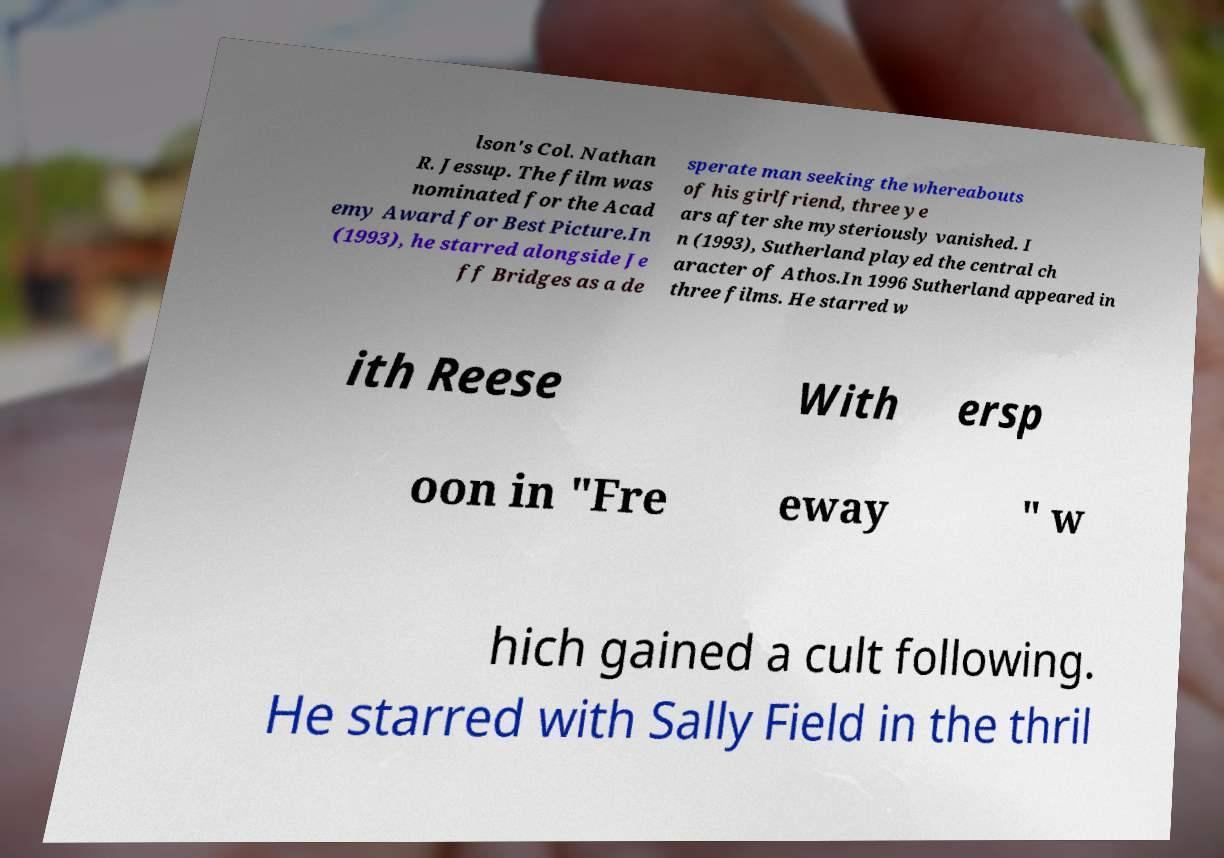Could you extract and type out the text from this image? lson's Col. Nathan R. Jessup. The film was nominated for the Acad emy Award for Best Picture.In (1993), he starred alongside Je ff Bridges as a de sperate man seeking the whereabouts of his girlfriend, three ye ars after she mysteriously vanished. I n (1993), Sutherland played the central ch aracter of Athos.In 1996 Sutherland appeared in three films. He starred w ith Reese With ersp oon in "Fre eway " w hich gained a cult following. He starred with Sally Field in the thril 